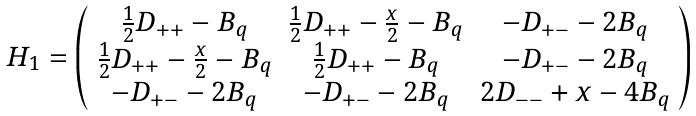Convert formula to latex. <formula><loc_0><loc_0><loc_500><loc_500>\begin{array} { c } H _ { 1 } = \left ( \begin{array} { c c c } \frac { 1 } { 2 } D _ { + + } - B _ { q } & \frac { 1 } { 2 } D _ { + + } - \frac { x } { 2 } - B _ { q } & - D _ { + - } - 2 B _ { q } \\ \frac { 1 } { 2 } D _ { + + } - \frac { x } { 2 } - B _ { q } & \frac { 1 } { 2 } D _ { + + } - B _ { q } & - D _ { + - } - 2 B _ { q } \\ - D _ { + - } - 2 B _ { q } & - D _ { + - } - 2 B _ { q } & 2 D _ { - - } + x - 4 B _ { q } \\ \end{array} \right ) \end{array}</formula> 